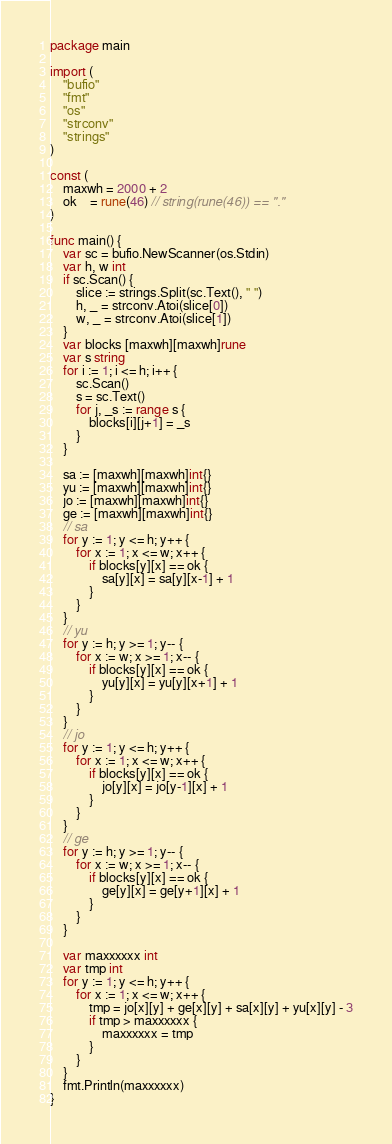Convert code to text. <code><loc_0><loc_0><loc_500><loc_500><_Go_>package main

import (
	"bufio"
	"fmt"
	"os"
	"strconv"
	"strings"
)

const (
	maxwh = 2000 + 2
	ok    = rune(46) // string(rune(46)) == "."
)

func main() {
	var sc = bufio.NewScanner(os.Stdin)
	var h, w int
	if sc.Scan() {
		slice := strings.Split(sc.Text(), " ")
		h, _ = strconv.Atoi(slice[0])
		w, _ = strconv.Atoi(slice[1])
	}
	var blocks [maxwh][maxwh]rune
	var s string
	for i := 1; i <= h; i++ {
		sc.Scan()
		s = sc.Text()
		for j, _s := range s {
			blocks[i][j+1] = _s
		}
	}

	sa := [maxwh][maxwh]int{}
	yu := [maxwh][maxwh]int{}
	jo := [maxwh][maxwh]int{}
	ge := [maxwh][maxwh]int{}
	// sa
	for y := 1; y <= h; y++ {
		for x := 1; x <= w; x++ {
			if blocks[y][x] == ok {
				sa[y][x] = sa[y][x-1] + 1
			}
		}
	}
	// yu
	for y := h; y >= 1; y-- {
		for x := w; x >= 1; x-- {
			if blocks[y][x] == ok {
				yu[y][x] = yu[y][x+1] + 1
			}
		}
	}
	// jo
	for y := 1; y <= h; y++ {
		for x := 1; x <= w; x++ {
			if blocks[y][x] == ok {
				jo[y][x] = jo[y-1][x] + 1
			}
		}
	}
	// ge
	for y := h; y >= 1; y-- {
		for x := w; x >= 1; x-- {
			if blocks[y][x] == ok {
				ge[y][x] = ge[y+1][x] + 1
			}
		}
	}

	var maxxxxxx int
	var tmp int
	for y := 1; y <= h; y++ {
		for x := 1; x <= w; x++ {
			tmp = jo[x][y] + ge[x][y] + sa[x][y] + yu[x][y] - 3
			if tmp > maxxxxxx {
				maxxxxxx = tmp
			}
		}
	}
	fmt.Println(maxxxxxx)
}
</code> 